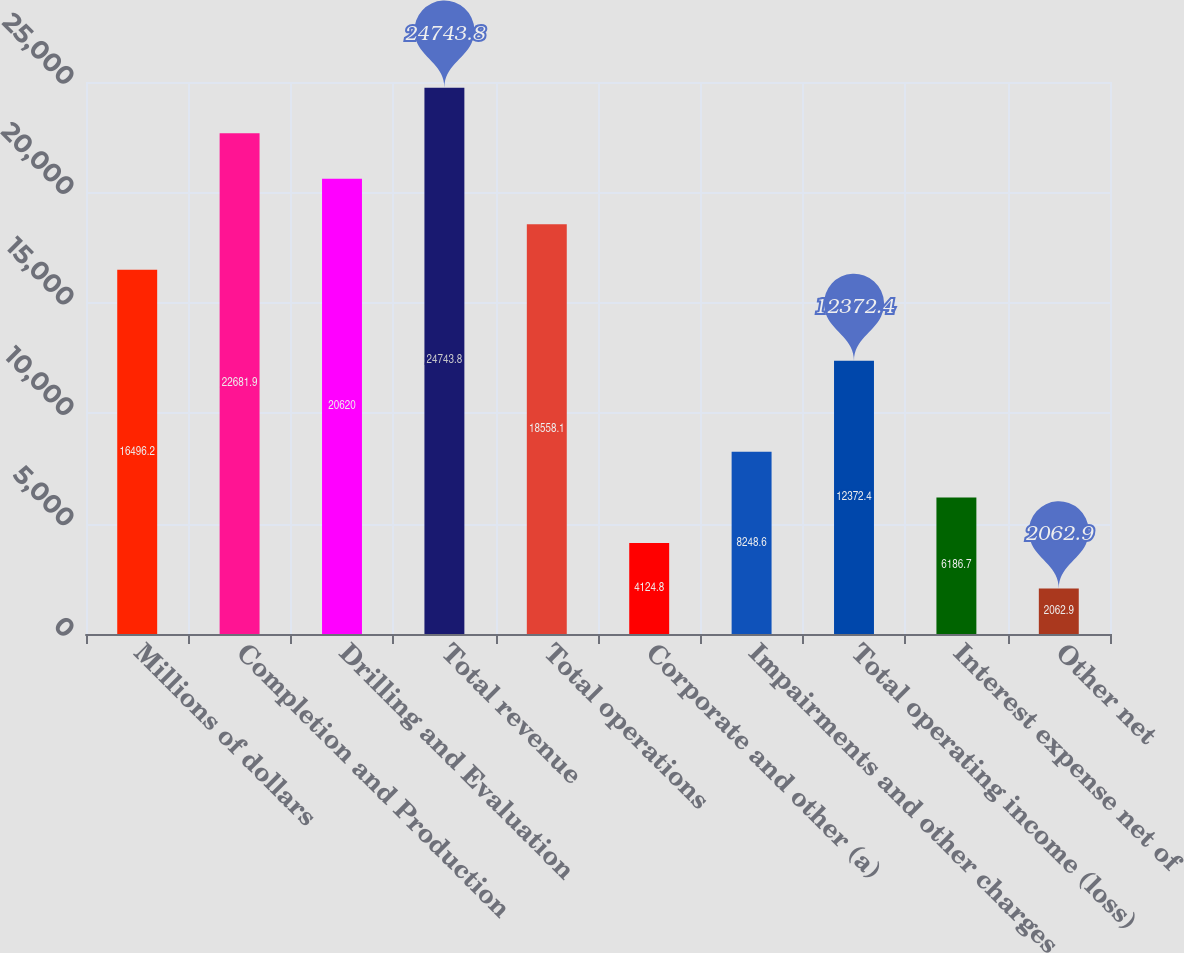<chart> <loc_0><loc_0><loc_500><loc_500><bar_chart><fcel>Millions of dollars<fcel>Completion and Production<fcel>Drilling and Evaluation<fcel>Total revenue<fcel>Total operations<fcel>Corporate and other (a)<fcel>Impairments and other charges<fcel>Total operating income (loss)<fcel>Interest expense net of<fcel>Other net<nl><fcel>16496.2<fcel>22681.9<fcel>20620<fcel>24743.8<fcel>18558.1<fcel>4124.8<fcel>8248.6<fcel>12372.4<fcel>6186.7<fcel>2062.9<nl></chart> 